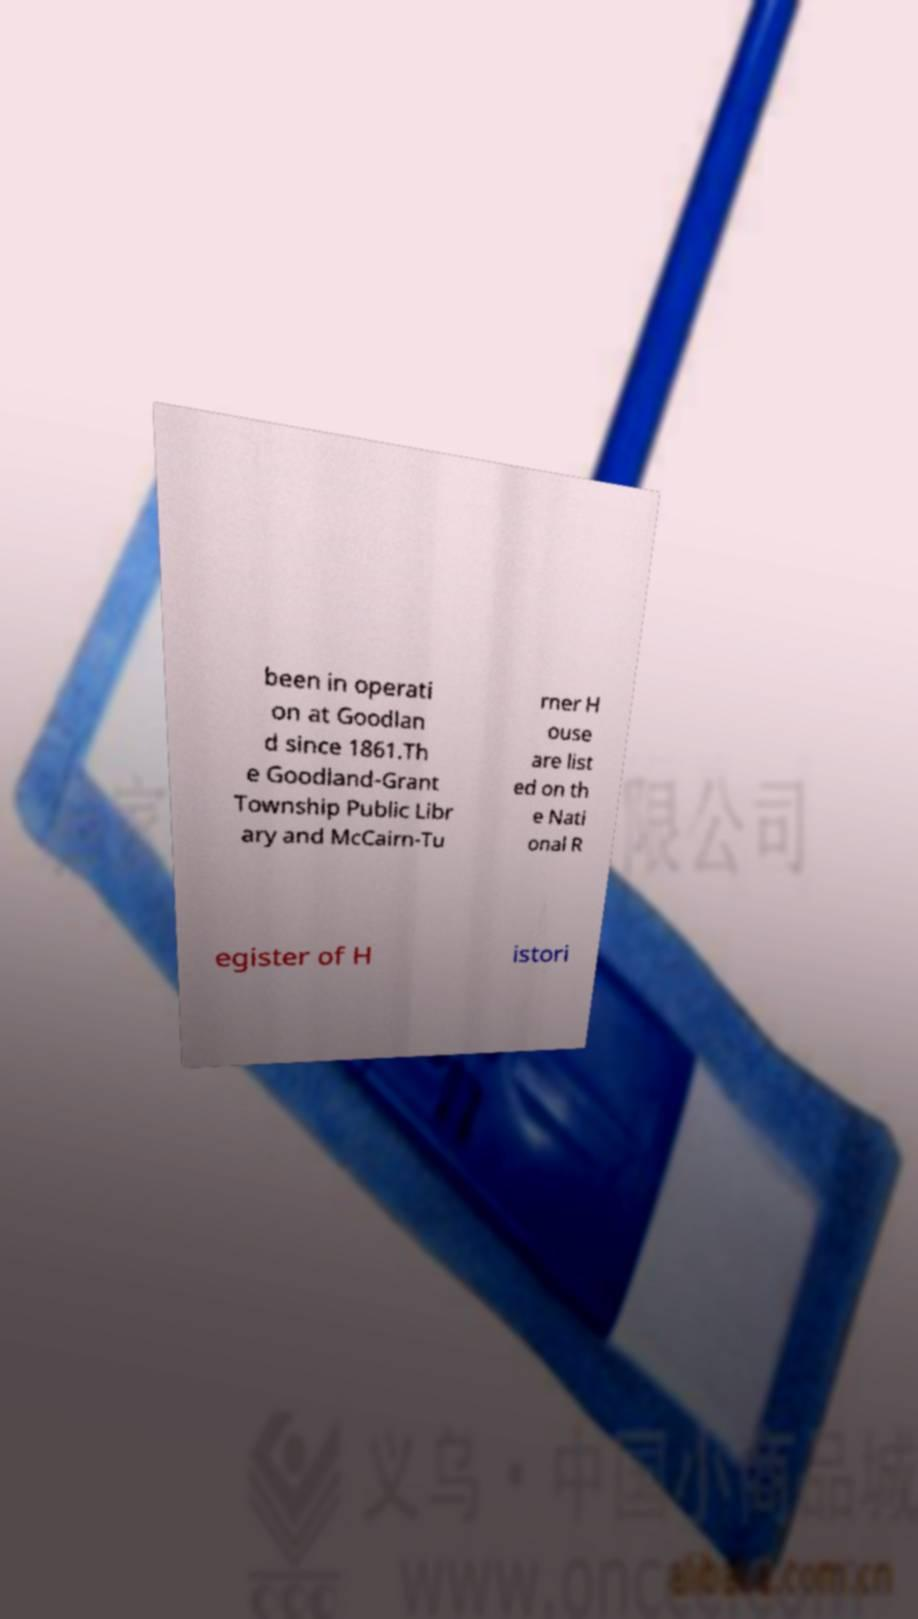Please identify and transcribe the text found in this image. been in operati on at Goodlan d since 1861.Th e Goodland-Grant Township Public Libr ary and McCairn-Tu rner H ouse are list ed on th e Nati onal R egister of H istori 